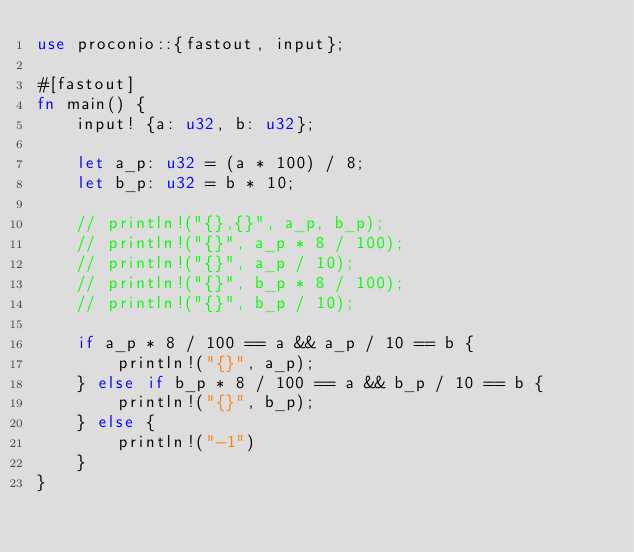<code> <loc_0><loc_0><loc_500><loc_500><_Rust_>use proconio::{fastout, input};

#[fastout]
fn main() {
    input! {a: u32, b: u32};

    let a_p: u32 = (a * 100) / 8;
    let b_p: u32 = b * 10;

    // println!("{},{}", a_p, b_p);
    // println!("{}", a_p * 8 / 100);
    // println!("{}", a_p / 10);
    // println!("{}", b_p * 8 / 100);
    // println!("{}", b_p / 10);

    if a_p * 8 / 100 == a && a_p / 10 == b {
        println!("{}", a_p);
    } else if b_p * 8 / 100 == a && b_p / 10 == b {
        println!("{}", b_p);
    } else {
        println!("-1")
    }
}
</code> 